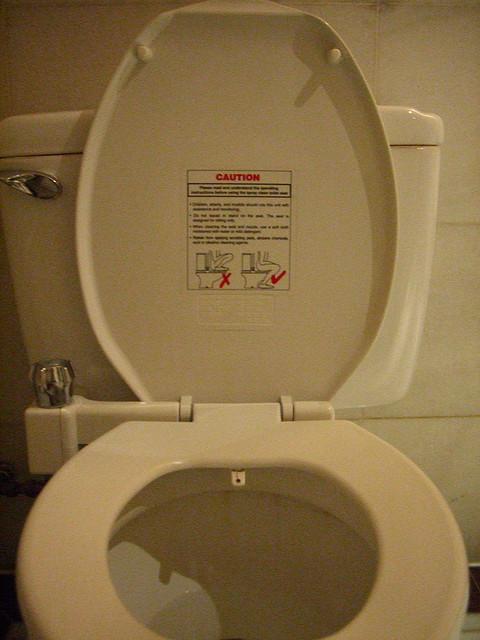Is there a caution on the toilet?
Concise answer only. Yes. What letters are on the bottom sticker?
Keep it brief. Caution. Is the toilet clean?
Quick response, please. Yes. Is the toilet seat up or down?
Quick response, please. Up. 